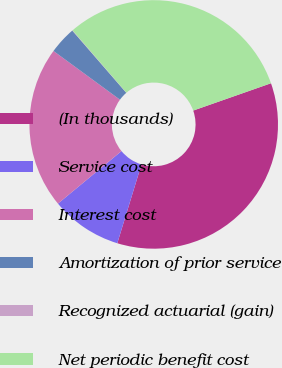<chart> <loc_0><loc_0><loc_500><loc_500><pie_chart><fcel>(In thousands)<fcel>Service cost<fcel>Interest cost<fcel>Amortization of prior service<fcel>Recognized actuarial (gain)<fcel>Net periodic benefit cost<nl><fcel>35.11%<fcel>9.27%<fcel>21.06%<fcel>3.56%<fcel>0.05%<fcel>30.95%<nl></chart> 